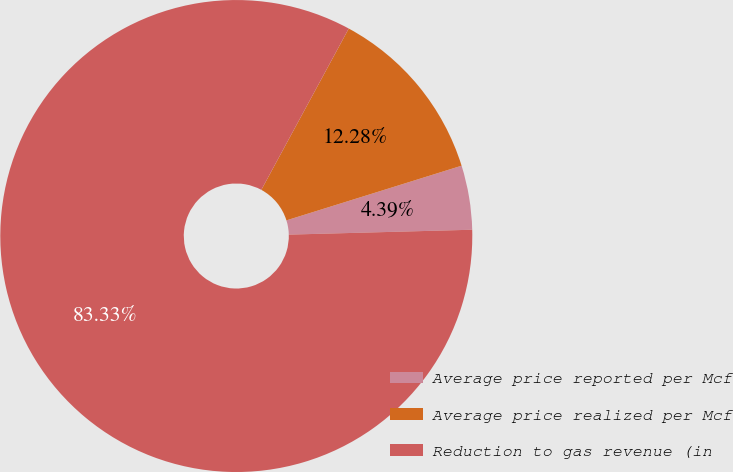<chart> <loc_0><loc_0><loc_500><loc_500><pie_chart><fcel>Average price reported per Mcf<fcel>Average price realized per Mcf<fcel>Reduction to gas revenue (in<nl><fcel>4.39%<fcel>12.28%<fcel>83.33%<nl></chart> 